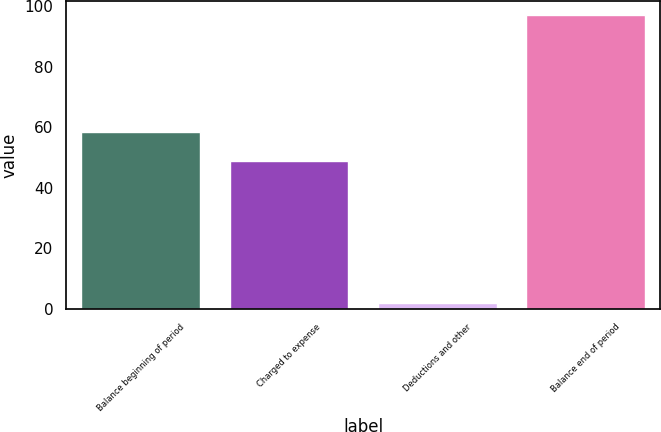Convert chart. <chart><loc_0><loc_0><loc_500><loc_500><bar_chart><fcel>Balance beginning of period<fcel>Charged to expense<fcel>Deductions and other<fcel>Balance end of period<nl><fcel>58.5<fcel>49<fcel>2<fcel>97<nl></chart> 